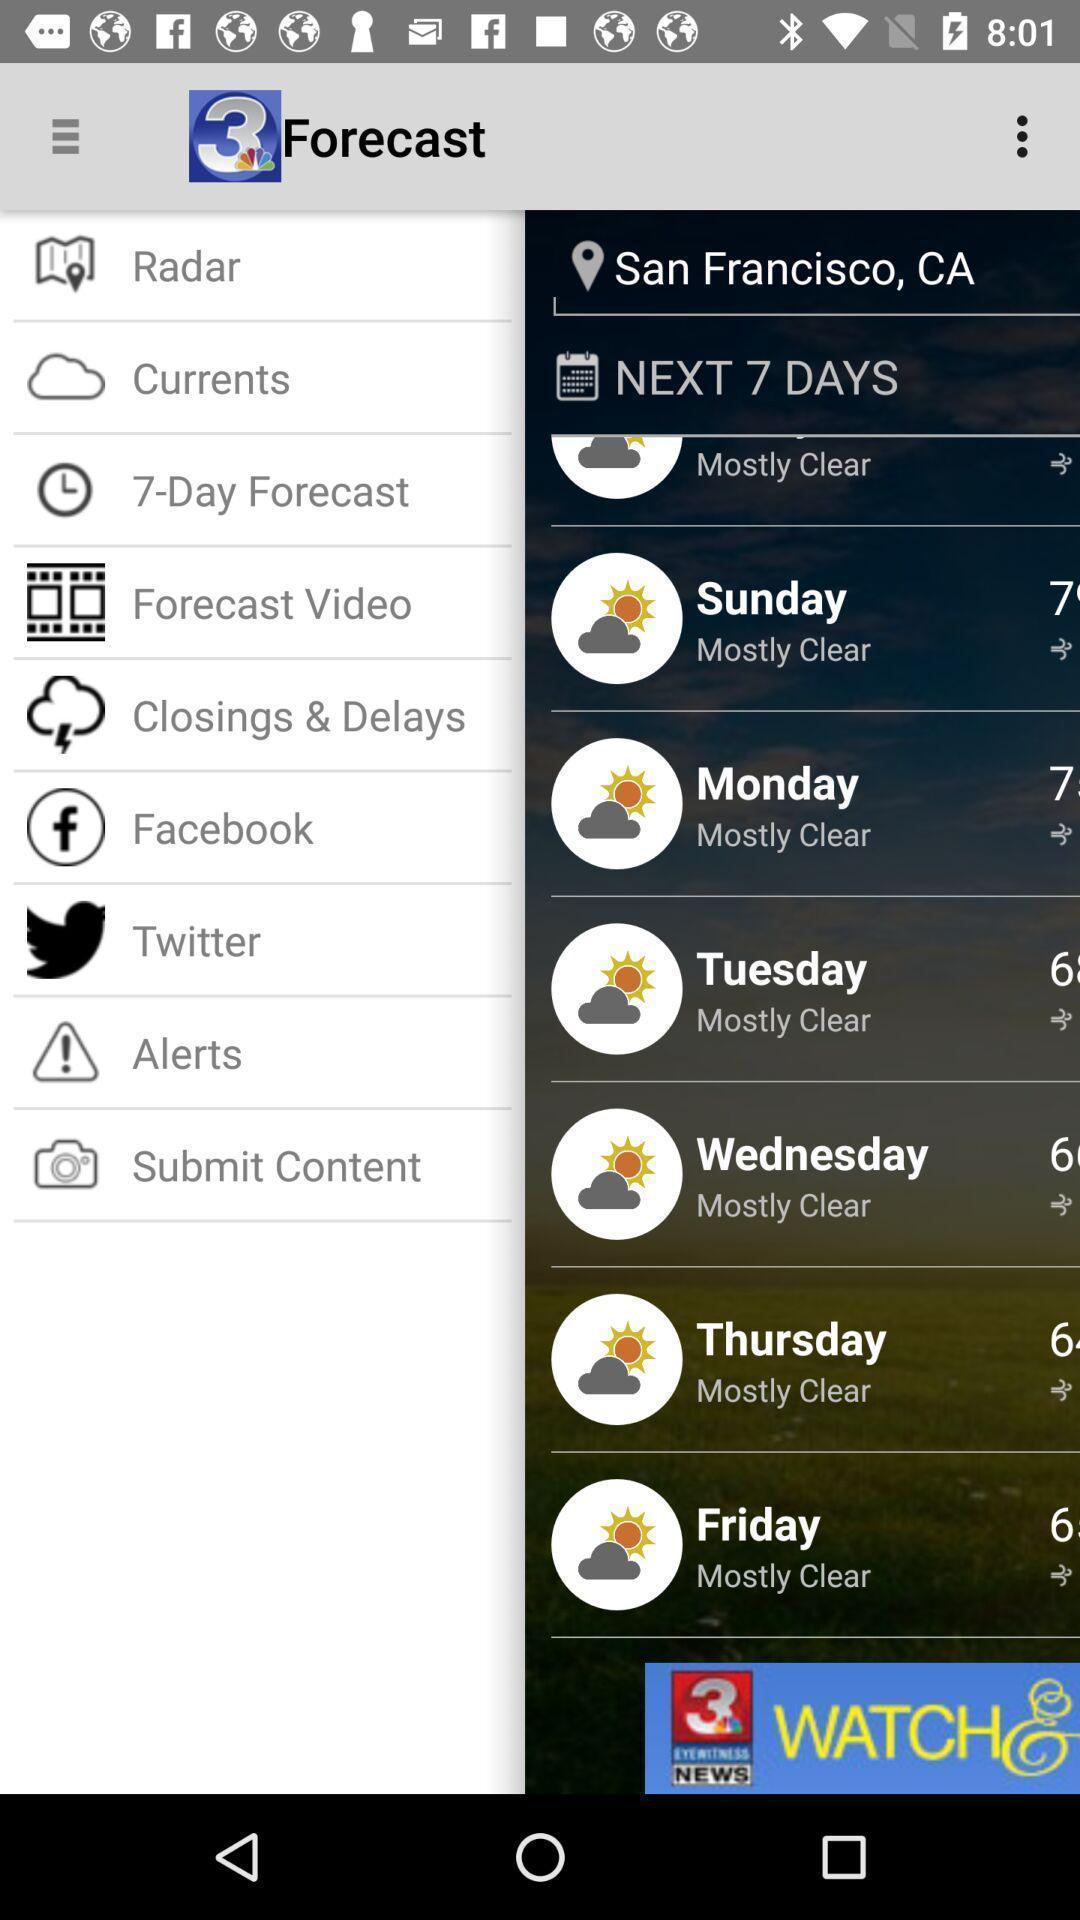Provide a description of this screenshot. Weather details of a location in a weather forecasting app. 